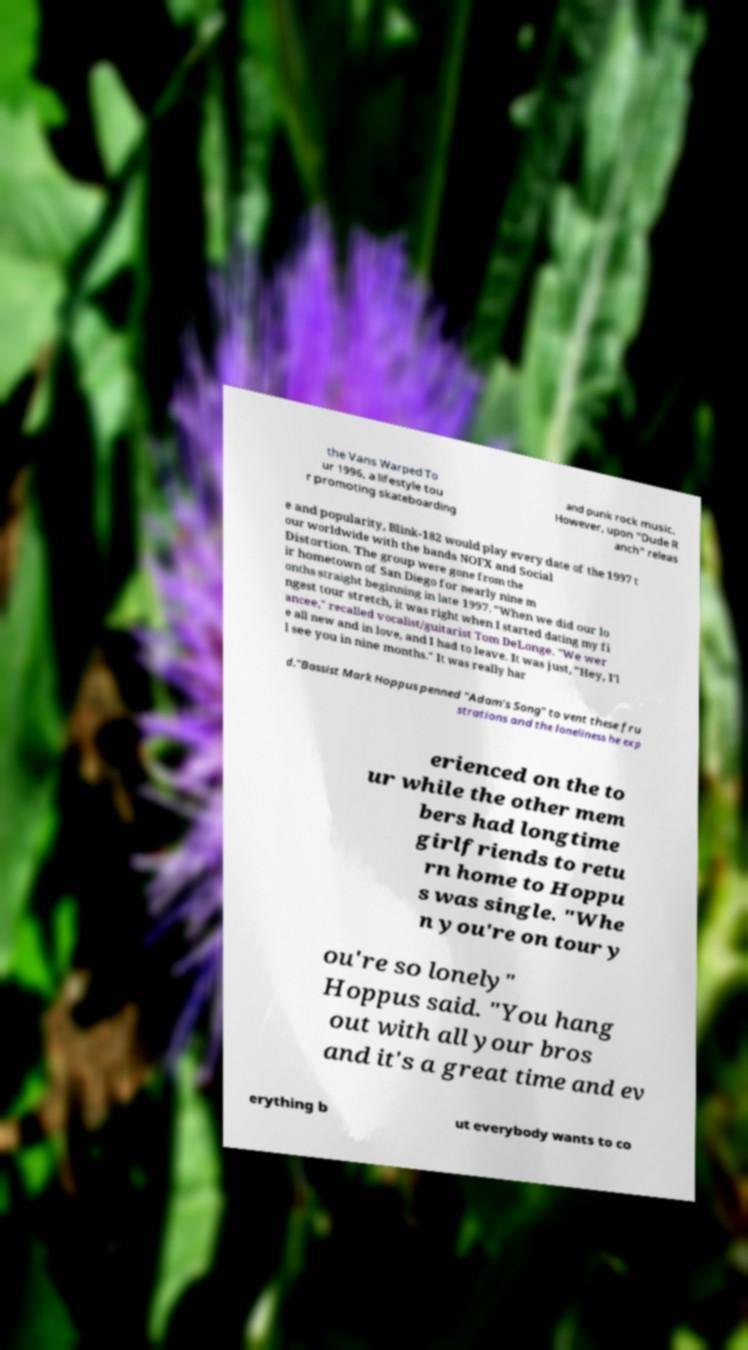Please read and relay the text visible in this image. What does it say? the Vans Warped To ur 1996, a lifestyle tou r promoting skateboarding and punk rock music. However, upon "Dude R anch" releas e and popularity, Blink-182 would play every date of the 1997 t our worldwide with the bands NOFX and Social Distortion. The group were gone from the ir hometown of San Diego for nearly nine m onths straight beginning in late 1997. "When we did our lo ngest tour stretch, it was right when I started dating my fi ancee," recalled vocalist/guitarist Tom DeLonge. "We wer e all new and in love, and I had to leave. It was just, "Hey, I'l l see you in nine months." It was really har d."Bassist Mark Hoppus penned "Adam's Song" to vent these fru strations and the loneliness he exp erienced on the to ur while the other mem bers had longtime girlfriends to retu rn home to Hoppu s was single. "Whe n you're on tour y ou're so lonely" Hoppus said. "You hang out with all your bros and it's a great time and ev erything b ut everybody wants to co 